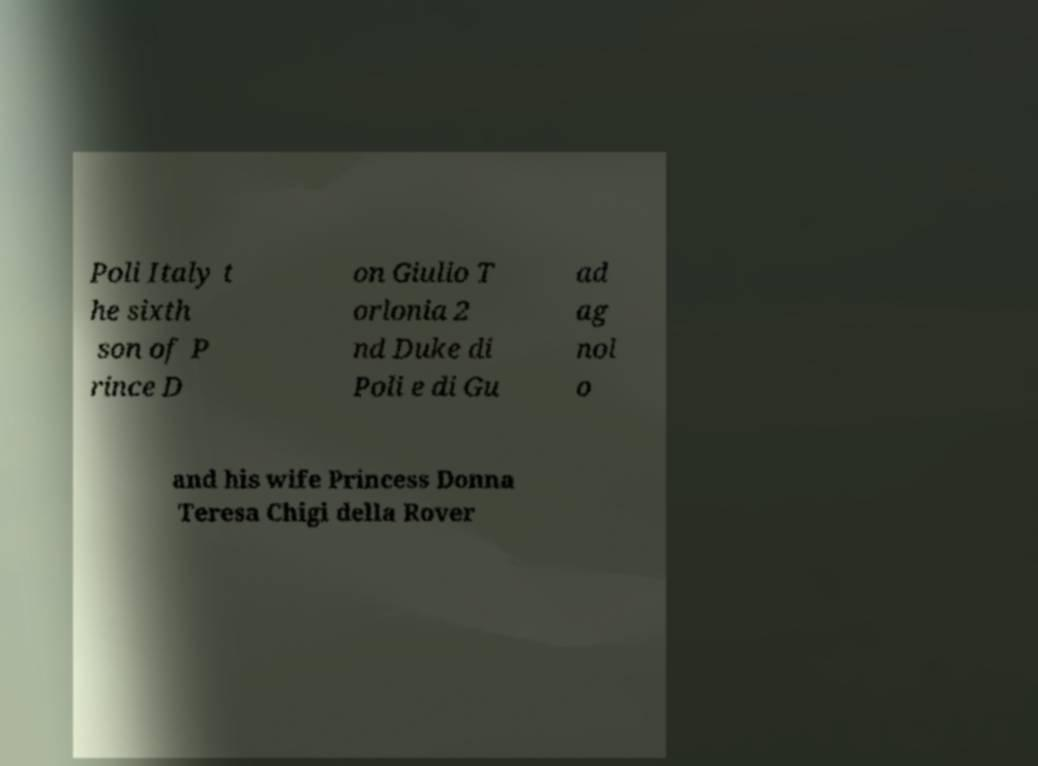Please identify and transcribe the text found in this image. Poli Italy t he sixth son of P rince D on Giulio T orlonia 2 nd Duke di Poli e di Gu ad ag nol o and his wife Princess Donna Teresa Chigi della Rover 